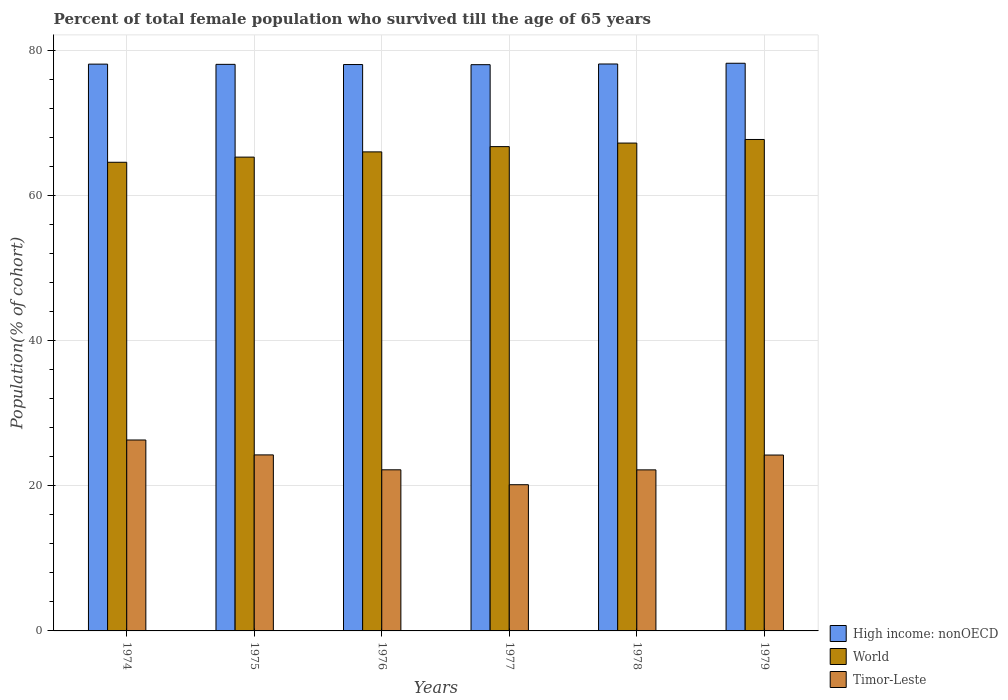How many bars are there on the 4th tick from the left?
Keep it short and to the point. 3. How many bars are there on the 3rd tick from the right?
Keep it short and to the point. 3. What is the label of the 2nd group of bars from the left?
Offer a terse response. 1975. What is the percentage of total female population who survived till the age of 65 years in High income: nonOECD in 1977?
Give a very brief answer. 78.05. Across all years, what is the maximum percentage of total female population who survived till the age of 65 years in High income: nonOECD?
Your answer should be very brief. 78.25. Across all years, what is the minimum percentage of total female population who survived till the age of 65 years in High income: nonOECD?
Ensure brevity in your answer.  78.05. In which year was the percentage of total female population who survived till the age of 65 years in World maximum?
Provide a succinct answer. 1979. In which year was the percentage of total female population who survived till the age of 65 years in World minimum?
Your answer should be compact. 1974. What is the total percentage of total female population who survived till the age of 65 years in World in the graph?
Offer a very short reply. 397.69. What is the difference between the percentage of total female population who survived till the age of 65 years in Timor-Leste in 1977 and that in 1978?
Offer a very short reply. -2.04. What is the difference between the percentage of total female population who survived till the age of 65 years in World in 1974 and the percentage of total female population who survived till the age of 65 years in High income: nonOECD in 1979?
Ensure brevity in your answer.  -13.65. What is the average percentage of total female population who survived till the age of 65 years in Timor-Leste per year?
Your answer should be very brief. 23.23. In the year 1977, what is the difference between the percentage of total female population who survived till the age of 65 years in Timor-Leste and percentage of total female population who survived till the age of 65 years in High income: nonOECD?
Offer a very short reply. -57.9. What is the ratio of the percentage of total female population who survived till the age of 65 years in Timor-Leste in 1975 to that in 1979?
Offer a very short reply. 1. Is the difference between the percentage of total female population who survived till the age of 65 years in Timor-Leste in 1974 and 1977 greater than the difference between the percentage of total female population who survived till the age of 65 years in High income: nonOECD in 1974 and 1977?
Make the answer very short. Yes. What is the difference between the highest and the second highest percentage of total female population who survived till the age of 65 years in High income: nonOECD?
Offer a very short reply. 0.1. What is the difference between the highest and the lowest percentage of total female population who survived till the age of 65 years in Timor-Leste?
Provide a succinct answer. 6.16. In how many years, is the percentage of total female population who survived till the age of 65 years in World greater than the average percentage of total female population who survived till the age of 65 years in World taken over all years?
Provide a succinct answer. 3. Is the sum of the percentage of total female population who survived till the age of 65 years in Timor-Leste in 1978 and 1979 greater than the maximum percentage of total female population who survived till the age of 65 years in World across all years?
Make the answer very short. No. Is it the case that in every year, the sum of the percentage of total female population who survived till the age of 65 years in High income: nonOECD and percentage of total female population who survived till the age of 65 years in Timor-Leste is greater than the percentage of total female population who survived till the age of 65 years in World?
Give a very brief answer. Yes. How many bars are there?
Provide a succinct answer. 18. Are all the bars in the graph horizontal?
Offer a terse response. No. How many years are there in the graph?
Make the answer very short. 6. What is the difference between two consecutive major ticks on the Y-axis?
Ensure brevity in your answer.  20. Does the graph contain any zero values?
Give a very brief answer. No. How many legend labels are there?
Your answer should be very brief. 3. What is the title of the graph?
Make the answer very short. Percent of total female population who survived till the age of 65 years. What is the label or title of the Y-axis?
Give a very brief answer. Population(% of cohort). What is the Population(% of cohort) in High income: nonOECD in 1974?
Provide a succinct answer. 78.13. What is the Population(% of cohort) in World in 1974?
Your response must be concise. 64.6. What is the Population(% of cohort) of Timor-Leste in 1974?
Keep it short and to the point. 26.32. What is the Population(% of cohort) in High income: nonOECD in 1975?
Your answer should be compact. 78.1. What is the Population(% of cohort) of World in 1975?
Your answer should be compact. 65.31. What is the Population(% of cohort) of Timor-Leste in 1975?
Your answer should be compact. 24.26. What is the Population(% of cohort) of High income: nonOECD in 1976?
Make the answer very short. 78.07. What is the Population(% of cohort) in World in 1976?
Your answer should be very brief. 66.03. What is the Population(% of cohort) in Timor-Leste in 1976?
Offer a very short reply. 22.21. What is the Population(% of cohort) in High income: nonOECD in 1977?
Make the answer very short. 78.05. What is the Population(% of cohort) in World in 1977?
Provide a short and direct response. 66.76. What is the Population(% of cohort) in Timor-Leste in 1977?
Offer a very short reply. 20.16. What is the Population(% of cohort) of High income: nonOECD in 1978?
Provide a succinct answer. 78.15. What is the Population(% of cohort) of World in 1978?
Give a very brief answer. 67.25. What is the Population(% of cohort) of Timor-Leste in 1978?
Your response must be concise. 22.2. What is the Population(% of cohort) in High income: nonOECD in 1979?
Your answer should be compact. 78.25. What is the Population(% of cohort) in World in 1979?
Provide a short and direct response. 67.74. What is the Population(% of cohort) of Timor-Leste in 1979?
Your answer should be very brief. 24.24. Across all years, what is the maximum Population(% of cohort) in High income: nonOECD?
Make the answer very short. 78.25. Across all years, what is the maximum Population(% of cohort) of World?
Make the answer very short. 67.74. Across all years, what is the maximum Population(% of cohort) of Timor-Leste?
Offer a very short reply. 26.32. Across all years, what is the minimum Population(% of cohort) in High income: nonOECD?
Your answer should be compact. 78.05. Across all years, what is the minimum Population(% of cohort) in World?
Provide a succinct answer. 64.6. Across all years, what is the minimum Population(% of cohort) of Timor-Leste?
Offer a very short reply. 20.16. What is the total Population(% of cohort) in High income: nonOECD in the graph?
Offer a very short reply. 468.75. What is the total Population(% of cohort) in World in the graph?
Keep it short and to the point. 397.69. What is the total Population(% of cohort) of Timor-Leste in the graph?
Your response must be concise. 139.39. What is the difference between the Population(% of cohort) in High income: nonOECD in 1974 and that in 1975?
Your answer should be very brief. 0.03. What is the difference between the Population(% of cohort) in World in 1974 and that in 1975?
Ensure brevity in your answer.  -0.71. What is the difference between the Population(% of cohort) of Timor-Leste in 1974 and that in 1975?
Your response must be concise. 2.05. What is the difference between the Population(% of cohort) of High income: nonOECD in 1974 and that in 1976?
Your answer should be compact. 0.06. What is the difference between the Population(% of cohort) in World in 1974 and that in 1976?
Offer a terse response. -1.43. What is the difference between the Population(% of cohort) in Timor-Leste in 1974 and that in 1976?
Give a very brief answer. 4.11. What is the difference between the Population(% of cohort) of High income: nonOECD in 1974 and that in 1977?
Provide a succinct answer. 0.07. What is the difference between the Population(% of cohort) in World in 1974 and that in 1977?
Ensure brevity in your answer.  -2.16. What is the difference between the Population(% of cohort) in Timor-Leste in 1974 and that in 1977?
Offer a very short reply. 6.16. What is the difference between the Population(% of cohort) in High income: nonOECD in 1974 and that in 1978?
Your answer should be compact. -0.02. What is the difference between the Population(% of cohort) in World in 1974 and that in 1978?
Give a very brief answer. -2.65. What is the difference between the Population(% of cohort) in Timor-Leste in 1974 and that in 1978?
Your response must be concise. 4.12. What is the difference between the Population(% of cohort) in High income: nonOECD in 1974 and that in 1979?
Offer a terse response. -0.12. What is the difference between the Population(% of cohort) in World in 1974 and that in 1979?
Your response must be concise. -3.14. What is the difference between the Population(% of cohort) in Timor-Leste in 1974 and that in 1979?
Your response must be concise. 2.08. What is the difference between the Population(% of cohort) in High income: nonOECD in 1975 and that in 1976?
Make the answer very short. 0.03. What is the difference between the Population(% of cohort) of World in 1975 and that in 1976?
Make the answer very short. -0.72. What is the difference between the Population(% of cohort) in Timor-Leste in 1975 and that in 1976?
Your answer should be compact. 2.05. What is the difference between the Population(% of cohort) of High income: nonOECD in 1975 and that in 1977?
Make the answer very short. 0.05. What is the difference between the Population(% of cohort) of World in 1975 and that in 1977?
Offer a terse response. -1.45. What is the difference between the Population(% of cohort) of Timor-Leste in 1975 and that in 1977?
Give a very brief answer. 4.11. What is the difference between the Population(% of cohort) in High income: nonOECD in 1975 and that in 1978?
Provide a short and direct response. -0.05. What is the difference between the Population(% of cohort) in World in 1975 and that in 1978?
Keep it short and to the point. -1.94. What is the difference between the Population(% of cohort) of Timor-Leste in 1975 and that in 1978?
Provide a succinct answer. 2.07. What is the difference between the Population(% of cohort) in High income: nonOECD in 1975 and that in 1979?
Your response must be concise. -0.15. What is the difference between the Population(% of cohort) of World in 1975 and that in 1979?
Ensure brevity in your answer.  -2.43. What is the difference between the Population(% of cohort) in Timor-Leste in 1975 and that in 1979?
Give a very brief answer. 0.02. What is the difference between the Population(% of cohort) of High income: nonOECD in 1976 and that in 1977?
Your response must be concise. 0.02. What is the difference between the Population(% of cohort) in World in 1976 and that in 1977?
Provide a succinct answer. -0.73. What is the difference between the Population(% of cohort) of Timor-Leste in 1976 and that in 1977?
Offer a very short reply. 2.05. What is the difference between the Population(% of cohort) in High income: nonOECD in 1976 and that in 1978?
Offer a very short reply. -0.07. What is the difference between the Population(% of cohort) of World in 1976 and that in 1978?
Make the answer very short. -1.22. What is the difference between the Population(% of cohort) of Timor-Leste in 1976 and that in 1978?
Offer a terse response. 0.01. What is the difference between the Population(% of cohort) of High income: nonOECD in 1976 and that in 1979?
Offer a very short reply. -0.18. What is the difference between the Population(% of cohort) in World in 1976 and that in 1979?
Your answer should be very brief. -1.71. What is the difference between the Population(% of cohort) of Timor-Leste in 1976 and that in 1979?
Offer a very short reply. -2.03. What is the difference between the Population(% of cohort) in High income: nonOECD in 1977 and that in 1978?
Your answer should be very brief. -0.09. What is the difference between the Population(% of cohort) of World in 1977 and that in 1978?
Your answer should be very brief. -0.49. What is the difference between the Population(% of cohort) of Timor-Leste in 1977 and that in 1978?
Provide a short and direct response. -2.04. What is the difference between the Population(% of cohort) in High income: nonOECD in 1977 and that in 1979?
Ensure brevity in your answer.  -0.19. What is the difference between the Population(% of cohort) of World in 1977 and that in 1979?
Offer a terse response. -0.98. What is the difference between the Population(% of cohort) in Timor-Leste in 1977 and that in 1979?
Make the answer very short. -4.09. What is the difference between the Population(% of cohort) in High income: nonOECD in 1978 and that in 1979?
Provide a short and direct response. -0.1. What is the difference between the Population(% of cohort) in World in 1978 and that in 1979?
Your response must be concise. -0.49. What is the difference between the Population(% of cohort) of Timor-Leste in 1978 and that in 1979?
Offer a very short reply. -2.04. What is the difference between the Population(% of cohort) of High income: nonOECD in 1974 and the Population(% of cohort) of World in 1975?
Keep it short and to the point. 12.82. What is the difference between the Population(% of cohort) of High income: nonOECD in 1974 and the Population(% of cohort) of Timor-Leste in 1975?
Provide a short and direct response. 53.86. What is the difference between the Population(% of cohort) of World in 1974 and the Population(% of cohort) of Timor-Leste in 1975?
Provide a short and direct response. 40.34. What is the difference between the Population(% of cohort) of High income: nonOECD in 1974 and the Population(% of cohort) of World in 1976?
Keep it short and to the point. 12.1. What is the difference between the Population(% of cohort) of High income: nonOECD in 1974 and the Population(% of cohort) of Timor-Leste in 1976?
Give a very brief answer. 55.92. What is the difference between the Population(% of cohort) of World in 1974 and the Population(% of cohort) of Timor-Leste in 1976?
Ensure brevity in your answer.  42.39. What is the difference between the Population(% of cohort) of High income: nonOECD in 1974 and the Population(% of cohort) of World in 1977?
Keep it short and to the point. 11.37. What is the difference between the Population(% of cohort) of High income: nonOECD in 1974 and the Population(% of cohort) of Timor-Leste in 1977?
Keep it short and to the point. 57.97. What is the difference between the Population(% of cohort) in World in 1974 and the Population(% of cohort) in Timor-Leste in 1977?
Provide a short and direct response. 44.44. What is the difference between the Population(% of cohort) in High income: nonOECD in 1974 and the Population(% of cohort) in World in 1978?
Provide a succinct answer. 10.88. What is the difference between the Population(% of cohort) of High income: nonOECD in 1974 and the Population(% of cohort) of Timor-Leste in 1978?
Your answer should be very brief. 55.93. What is the difference between the Population(% of cohort) of World in 1974 and the Population(% of cohort) of Timor-Leste in 1978?
Your response must be concise. 42.4. What is the difference between the Population(% of cohort) of High income: nonOECD in 1974 and the Population(% of cohort) of World in 1979?
Give a very brief answer. 10.39. What is the difference between the Population(% of cohort) in High income: nonOECD in 1974 and the Population(% of cohort) in Timor-Leste in 1979?
Give a very brief answer. 53.89. What is the difference between the Population(% of cohort) of World in 1974 and the Population(% of cohort) of Timor-Leste in 1979?
Your answer should be compact. 40.36. What is the difference between the Population(% of cohort) in High income: nonOECD in 1975 and the Population(% of cohort) in World in 1976?
Provide a short and direct response. 12.07. What is the difference between the Population(% of cohort) in High income: nonOECD in 1975 and the Population(% of cohort) in Timor-Leste in 1976?
Make the answer very short. 55.89. What is the difference between the Population(% of cohort) of World in 1975 and the Population(% of cohort) of Timor-Leste in 1976?
Provide a short and direct response. 43.1. What is the difference between the Population(% of cohort) in High income: nonOECD in 1975 and the Population(% of cohort) in World in 1977?
Keep it short and to the point. 11.34. What is the difference between the Population(% of cohort) in High income: nonOECD in 1975 and the Population(% of cohort) in Timor-Leste in 1977?
Your answer should be very brief. 57.94. What is the difference between the Population(% of cohort) of World in 1975 and the Population(% of cohort) of Timor-Leste in 1977?
Ensure brevity in your answer.  45.16. What is the difference between the Population(% of cohort) in High income: nonOECD in 1975 and the Population(% of cohort) in World in 1978?
Your response must be concise. 10.85. What is the difference between the Population(% of cohort) in High income: nonOECD in 1975 and the Population(% of cohort) in Timor-Leste in 1978?
Your answer should be very brief. 55.9. What is the difference between the Population(% of cohort) of World in 1975 and the Population(% of cohort) of Timor-Leste in 1978?
Keep it short and to the point. 43.11. What is the difference between the Population(% of cohort) of High income: nonOECD in 1975 and the Population(% of cohort) of World in 1979?
Your response must be concise. 10.36. What is the difference between the Population(% of cohort) in High income: nonOECD in 1975 and the Population(% of cohort) in Timor-Leste in 1979?
Your answer should be very brief. 53.86. What is the difference between the Population(% of cohort) of World in 1975 and the Population(% of cohort) of Timor-Leste in 1979?
Your answer should be very brief. 41.07. What is the difference between the Population(% of cohort) in High income: nonOECD in 1976 and the Population(% of cohort) in World in 1977?
Provide a short and direct response. 11.31. What is the difference between the Population(% of cohort) in High income: nonOECD in 1976 and the Population(% of cohort) in Timor-Leste in 1977?
Provide a short and direct response. 57.92. What is the difference between the Population(% of cohort) in World in 1976 and the Population(% of cohort) in Timor-Leste in 1977?
Keep it short and to the point. 45.88. What is the difference between the Population(% of cohort) of High income: nonOECD in 1976 and the Population(% of cohort) of World in 1978?
Offer a terse response. 10.82. What is the difference between the Population(% of cohort) of High income: nonOECD in 1976 and the Population(% of cohort) of Timor-Leste in 1978?
Your answer should be compact. 55.87. What is the difference between the Population(% of cohort) in World in 1976 and the Population(% of cohort) in Timor-Leste in 1978?
Your answer should be compact. 43.83. What is the difference between the Population(% of cohort) of High income: nonOECD in 1976 and the Population(% of cohort) of World in 1979?
Your response must be concise. 10.33. What is the difference between the Population(% of cohort) of High income: nonOECD in 1976 and the Population(% of cohort) of Timor-Leste in 1979?
Ensure brevity in your answer.  53.83. What is the difference between the Population(% of cohort) of World in 1976 and the Population(% of cohort) of Timor-Leste in 1979?
Your answer should be very brief. 41.79. What is the difference between the Population(% of cohort) of High income: nonOECD in 1977 and the Population(% of cohort) of World in 1978?
Your answer should be compact. 10.81. What is the difference between the Population(% of cohort) in High income: nonOECD in 1977 and the Population(% of cohort) in Timor-Leste in 1978?
Provide a succinct answer. 55.85. What is the difference between the Population(% of cohort) in World in 1977 and the Population(% of cohort) in Timor-Leste in 1978?
Offer a terse response. 44.56. What is the difference between the Population(% of cohort) of High income: nonOECD in 1977 and the Population(% of cohort) of World in 1979?
Make the answer very short. 10.31. What is the difference between the Population(% of cohort) of High income: nonOECD in 1977 and the Population(% of cohort) of Timor-Leste in 1979?
Your answer should be very brief. 53.81. What is the difference between the Population(% of cohort) of World in 1977 and the Population(% of cohort) of Timor-Leste in 1979?
Give a very brief answer. 42.51. What is the difference between the Population(% of cohort) of High income: nonOECD in 1978 and the Population(% of cohort) of World in 1979?
Provide a succinct answer. 10.4. What is the difference between the Population(% of cohort) in High income: nonOECD in 1978 and the Population(% of cohort) in Timor-Leste in 1979?
Your response must be concise. 53.9. What is the difference between the Population(% of cohort) in World in 1978 and the Population(% of cohort) in Timor-Leste in 1979?
Offer a very short reply. 43. What is the average Population(% of cohort) of High income: nonOECD per year?
Your answer should be compact. 78.12. What is the average Population(% of cohort) in World per year?
Ensure brevity in your answer.  66.28. What is the average Population(% of cohort) in Timor-Leste per year?
Ensure brevity in your answer.  23.23. In the year 1974, what is the difference between the Population(% of cohort) in High income: nonOECD and Population(% of cohort) in World?
Make the answer very short. 13.53. In the year 1974, what is the difference between the Population(% of cohort) in High income: nonOECD and Population(% of cohort) in Timor-Leste?
Make the answer very short. 51.81. In the year 1974, what is the difference between the Population(% of cohort) of World and Population(% of cohort) of Timor-Leste?
Provide a succinct answer. 38.28. In the year 1975, what is the difference between the Population(% of cohort) of High income: nonOECD and Population(% of cohort) of World?
Keep it short and to the point. 12.79. In the year 1975, what is the difference between the Population(% of cohort) of High income: nonOECD and Population(% of cohort) of Timor-Leste?
Give a very brief answer. 53.83. In the year 1975, what is the difference between the Population(% of cohort) in World and Population(% of cohort) in Timor-Leste?
Provide a succinct answer. 41.05. In the year 1976, what is the difference between the Population(% of cohort) in High income: nonOECD and Population(% of cohort) in World?
Offer a very short reply. 12.04. In the year 1976, what is the difference between the Population(% of cohort) of High income: nonOECD and Population(% of cohort) of Timor-Leste?
Your answer should be compact. 55.86. In the year 1976, what is the difference between the Population(% of cohort) in World and Population(% of cohort) in Timor-Leste?
Provide a succinct answer. 43.82. In the year 1977, what is the difference between the Population(% of cohort) of High income: nonOECD and Population(% of cohort) of World?
Keep it short and to the point. 11.3. In the year 1977, what is the difference between the Population(% of cohort) in High income: nonOECD and Population(% of cohort) in Timor-Leste?
Your answer should be very brief. 57.9. In the year 1977, what is the difference between the Population(% of cohort) in World and Population(% of cohort) in Timor-Leste?
Give a very brief answer. 46.6. In the year 1978, what is the difference between the Population(% of cohort) in High income: nonOECD and Population(% of cohort) in World?
Your answer should be very brief. 10.9. In the year 1978, what is the difference between the Population(% of cohort) of High income: nonOECD and Population(% of cohort) of Timor-Leste?
Your answer should be compact. 55.95. In the year 1978, what is the difference between the Population(% of cohort) of World and Population(% of cohort) of Timor-Leste?
Provide a short and direct response. 45.05. In the year 1979, what is the difference between the Population(% of cohort) in High income: nonOECD and Population(% of cohort) in World?
Keep it short and to the point. 10.51. In the year 1979, what is the difference between the Population(% of cohort) in High income: nonOECD and Population(% of cohort) in Timor-Leste?
Give a very brief answer. 54.01. In the year 1979, what is the difference between the Population(% of cohort) in World and Population(% of cohort) in Timor-Leste?
Your response must be concise. 43.5. What is the ratio of the Population(% of cohort) in World in 1974 to that in 1975?
Ensure brevity in your answer.  0.99. What is the ratio of the Population(% of cohort) of Timor-Leste in 1974 to that in 1975?
Make the answer very short. 1.08. What is the ratio of the Population(% of cohort) in World in 1974 to that in 1976?
Make the answer very short. 0.98. What is the ratio of the Population(% of cohort) of Timor-Leste in 1974 to that in 1976?
Give a very brief answer. 1.19. What is the ratio of the Population(% of cohort) in High income: nonOECD in 1974 to that in 1977?
Offer a very short reply. 1. What is the ratio of the Population(% of cohort) of World in 1974 to that in 1977?
Offer a terse response. 0.97. What is the ratio of the Population(% of cohort) in Timor-Leste in 1974 to that in 1977?
Give a very brief answer. 1.31. What is the ratio of the Population(% of cohort) of World in 1974 to that in 1978?
Make the answer very short. 0.96. What is the ratio of the Population(% of cohort) of Timor-Leste in 1974 to that in 1978?
Your answer should be very brief. 1.19. What is the ratio of the Population(% of cohort) in High income: nonOECD in 1974 to that in 1979?
Give a very brief answer. 1. What is the ratio of the Population(% of cohort) in World in 1974 to that in 1979?
Give a very brief answer. 0.95. What is the ratio of the Population(% of cohort) in Timor-Leste in 1974 to that in 1979?
Make the answer very short. 1.09. What is the ratio of the Population(% of cohort) in Timor-Leste in 1975 to that in 1976?
Make the answer very short. 1.09. What is the ratio of the Population(% of cohort) in World in 1975 to that in 1977?
Your response must be concise. 0.98. What is the ratio of the Population(% of cohort) in Timor-Leste in 1975 to that in 1977?
Make the answer very short. 1.2. What is the ratio of the Population(% of cohort) in High income: nonOECD in 1975 to that in 1978?
Keep it short and to the point. 1. What is the ratio of the Population(% of cohort) of World in 1975 to that in 1978?
Your answer should be very brief. 0.97. What is the ratio of the Population(% of cohort) of Timor-Leste in 1975 to that in 1978?
Offer a very short reply. 1.09. What is the ratio of the Population(% of cohort) of High income: nonOECD in 1975 to that in 1979?
Your response must be concise. 1. What is the ratio of the Population(% of cohort) of World in 1975 to that in 1979?
Make the answer very short. 0.96. What is the ratio of the Population(% of cohort) of Timor-Leste in 1975 to that in 1979?
Your response must be concise. 1. What is the ratio of the Population(% of cohort) in High income: nonOECD in 1976 to that in 1977?
Make the answer very short. 1. What is the ratio of the Population(% of cohort) in Timor-Leste in 1976 to that in 1977?
Your answer should be very brief. 1.1. What is the ratio of the Population(% of cohort) of World in 1976 to that in 1978?
Make the answer very short. 0.98. What is the ratio of the Population(% of cohort) of Timor-Leste in 1976 to that in 1978?
Provide a succinct answer. 1. What is the ratio of the Population(% of cohort) in World in 1976 to that in 1979?
Ensure brevity in your answer.  0.97. What is the ratio of the Population(% of cohort) in Timor-Leste in 1976 to that in 1979?
Your answer should be very brief. 0.92. What is the ratio of the Population(% of cohort) of High income: nonOECD in 1977 to that in 1978?
Ensure brevity in your answer.  1. What is the ratio of the Population(% of cohort) in Timor-Leste in 1977 to that in 1978?
Offer a very short reply. 0.91. What is the ratio of the Population(% of cohort) of High income: nonOECD in 1977 to that in 1979?
Offer a very short reply. 1. What is the ratio of the Population(% of cohort) in World in 1977 to that in 1979?
Make the answer very short. 0.99. What is the ratio of the Population(% of cohort) of Timor-Leste in 1977 to that in 1979?
Give a very brief answer. 0.83. What is the ratio of the Population(% of cohort) of High income: nonOECD in 1978 to that in 1979?
Ensure brevity in your answer.  1. What is the ratio of the Population(% of cohort) of World in 1978 to that in 1979?
Your answer should be compact. 0.99. What is the ratio of the Population(% of cohort) in Timor-Leste in 1978 to that in 1979?
Your response must be concise. 0.92. What is the difference between the highest and the second highest Population(% of cohort) in High income: nonOECD?
Offer a very short reply. 0.1. What is the difference between the highest and the second highest Population(% of cohort) in World?
Ensure brevity in your answer.  0.49. What is the difference between the highest and the second highest Population(% of cohort) of Timor-Leste?
Give a very brief answer. 2.05. What is the difference between the highest and the lowest Population(% of cohort) of High income: nonOECD?
Keep it short and to the point. 0.19. What is the difference between the highest and the lowest Population(% of cohort) in World?
Your answer should be compact. 3.14. What is the difference between the highest and the lowest Population(% of cohort) in Timor-Leste?
Offer a very short reply. 6.16. 